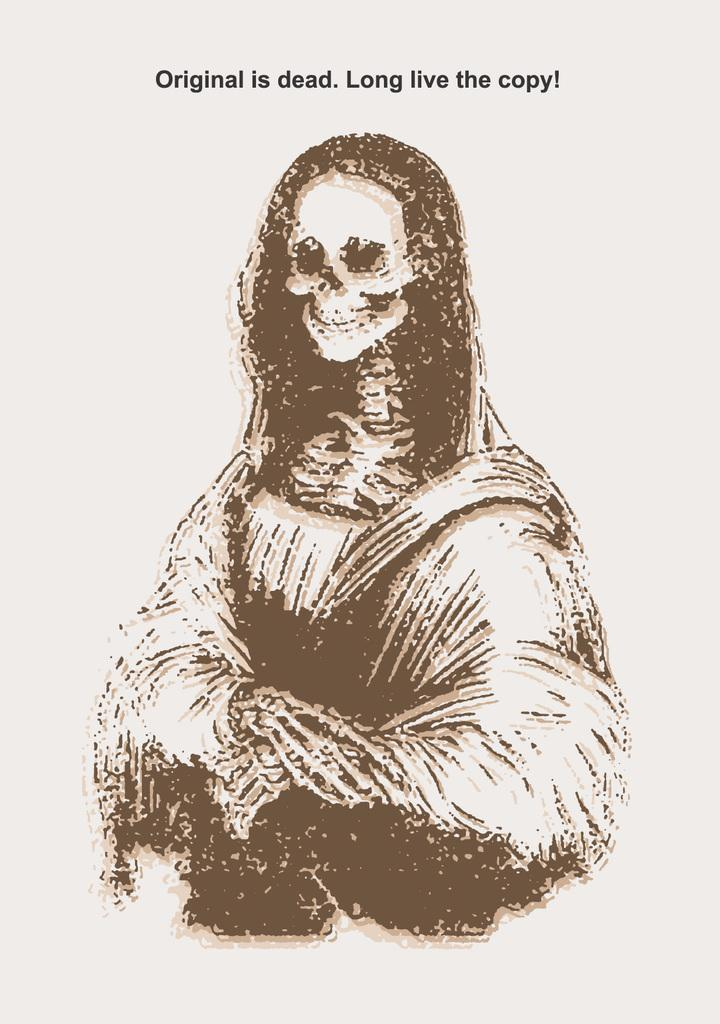What is the main subject of the image? The main subject of the image is a picture. Can you describe any additional details about the picture? Yes, there is text written at the bottom of the picture. What type of spark can be seen coming from the picture in the image? There is no spark present in the image; it only features a picture with text at the bottom. 